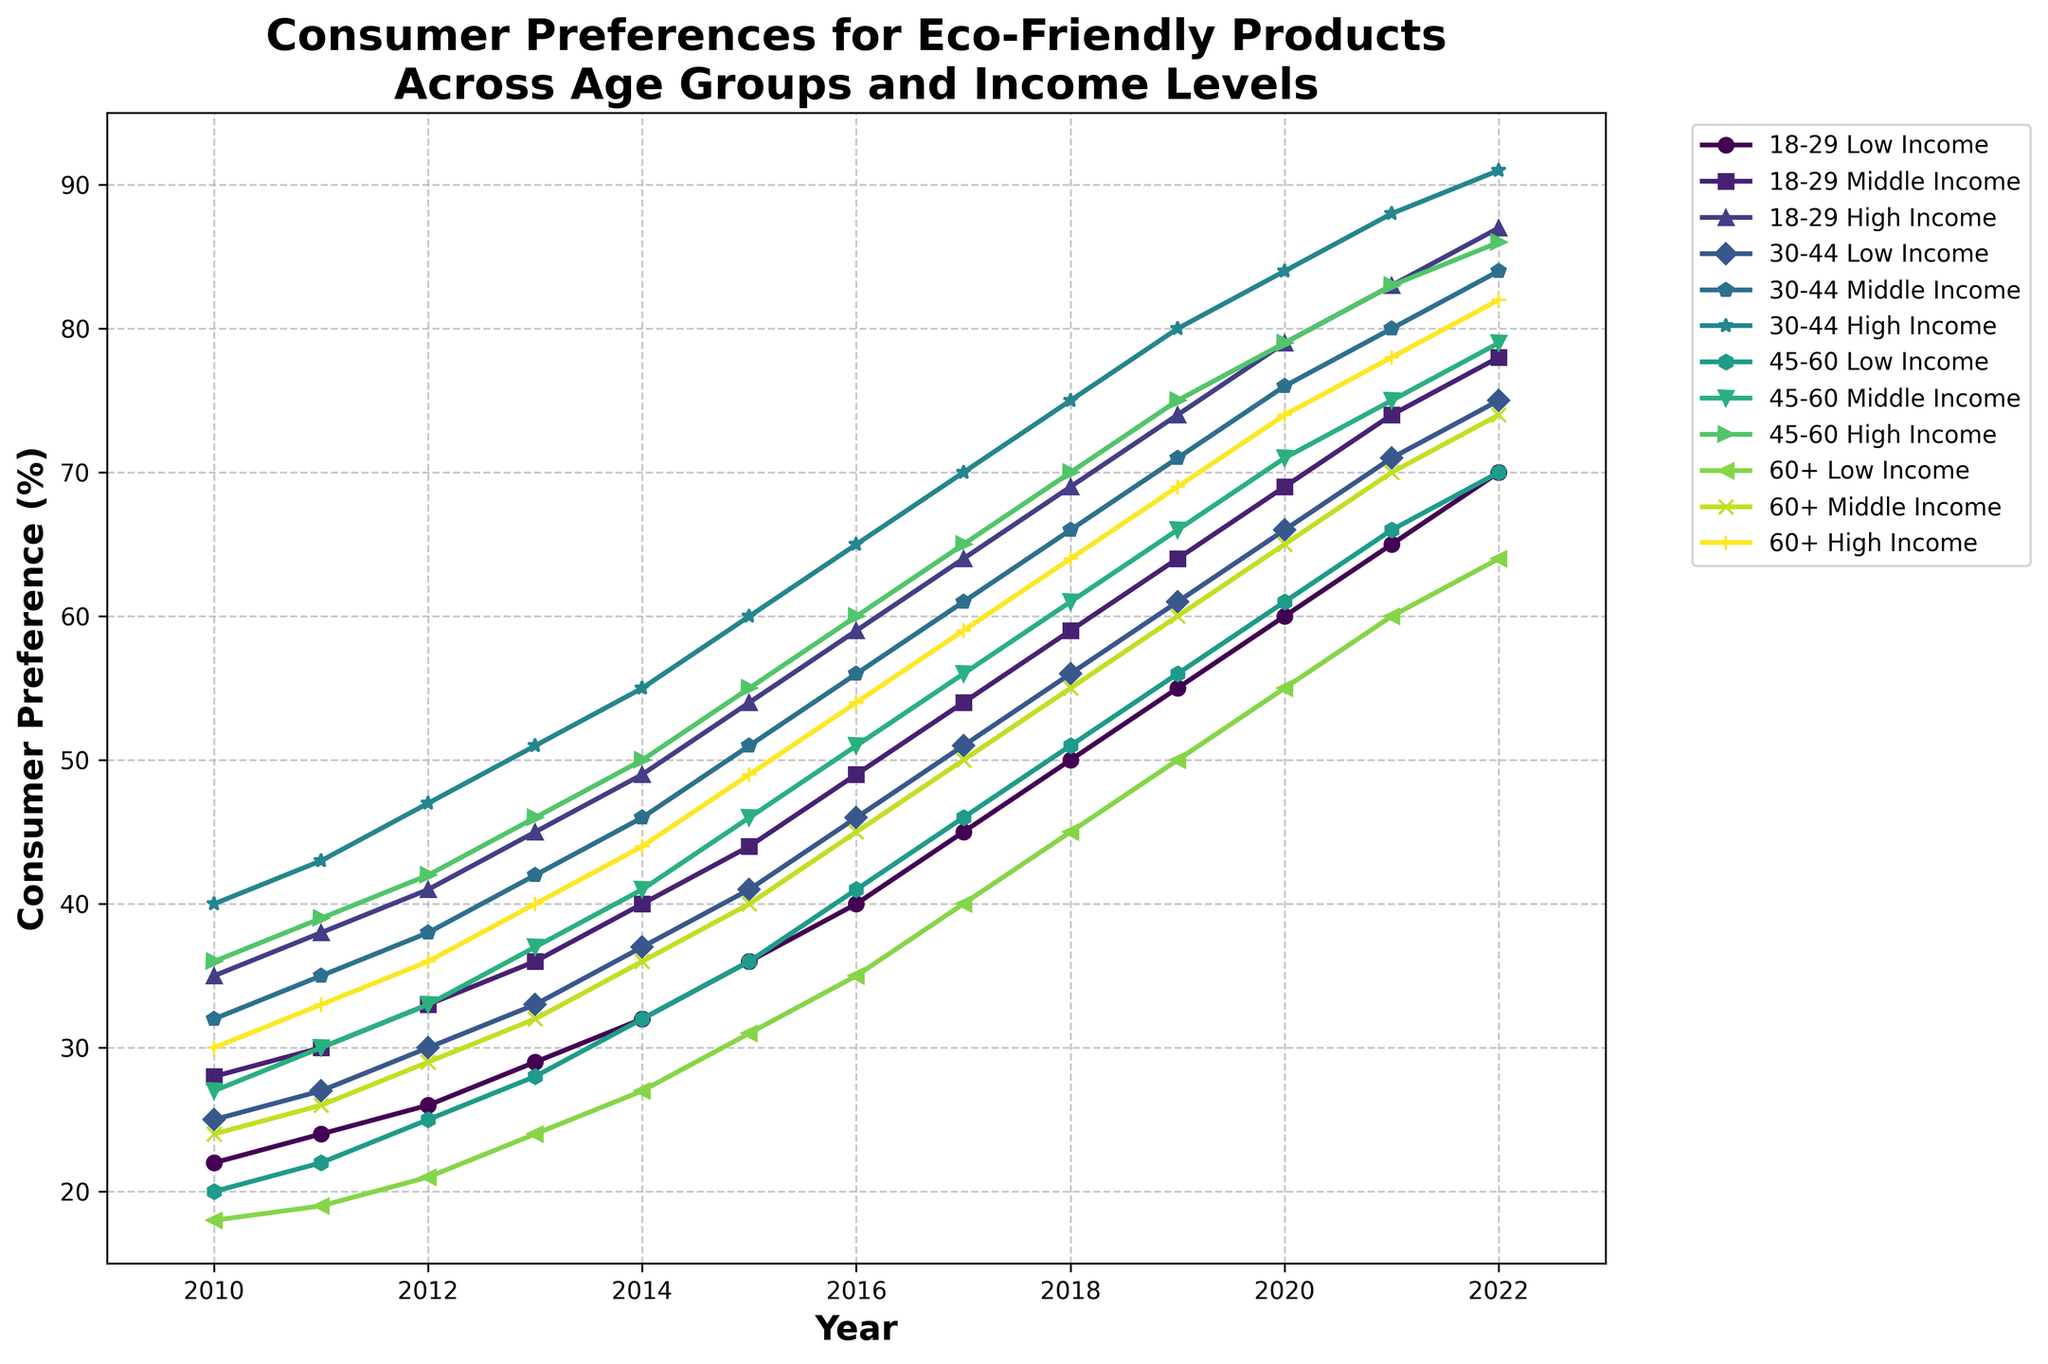How have the preferences of the 18-29 high-income group changed from 2010 to 2022? The line chart shows the preferences of the 18-29 high-income group rising steadily from 35% in 2010 to 87% in 2022. To determine this, look at the specific line representing this group and note the values at the start and end of the observed period.
Answer: From 35% to 87% Compare the preferences between the 30-44 middle-income group and the 45-60 middle-income group in 2017. Which group had higher preferences? In 2017, the preference of the 30-44 middle-income group is at 61%, while the 45-60 middle-income group is at 56%. Look for the corresponding lines and their exact values for that year.
Answer: 30-44 middle-income group Which age group and income level had the lowest preference for eco-friendly products in 2010? In 2010, the 60+ low-income group had a preference of 18%, which is the lowest among all groups. Scan the chart from 2010 and identify the lowest data point.
Answer: 60+ low-income group What is the average preference for eco-friendly products across all age groups and income levels in 2022? To calculate the average preference in 2022, sum all the preferences for that year: (70 + 78 + 87 + 75 + 84 + 91 + 70 + 79 + 86 + 64 + 74 + 82) = 940. Divide by the number of groups (12): 940 / 12 ≈ 78.33%.
Answer: ≈ 78.33% How much did the preference for eco-friendly products increase for the 45-60 high-income group from 2015 to 2020? In 2015, the preference for the 45-60 high-income group was 55%, and in 2020, it was 79%. Calculate the increase: 79% - 55% = 24%.
Answer: 24% Which group showed the greatest absolute increase in preference for eco-friendly products from 2010 to 2022? To find the greatest absolute increase, calculate the difference for each group from 2010 to 2022. The 18-29 high-income group increased from 35% to 87%, a difference of 52%, which is the highest.
Answer: 18-29 high-income group Did the preferences for eco-friendly products in the 60+ middle-income group ever surpass 50% and when? In the year 2020, the preferences for the 60+ middle-income group reached 65%, surpassing 50% for the first time. This can be noted by following the 60+ middle-income group's line across the years.
Answer: Yes, in 2020 